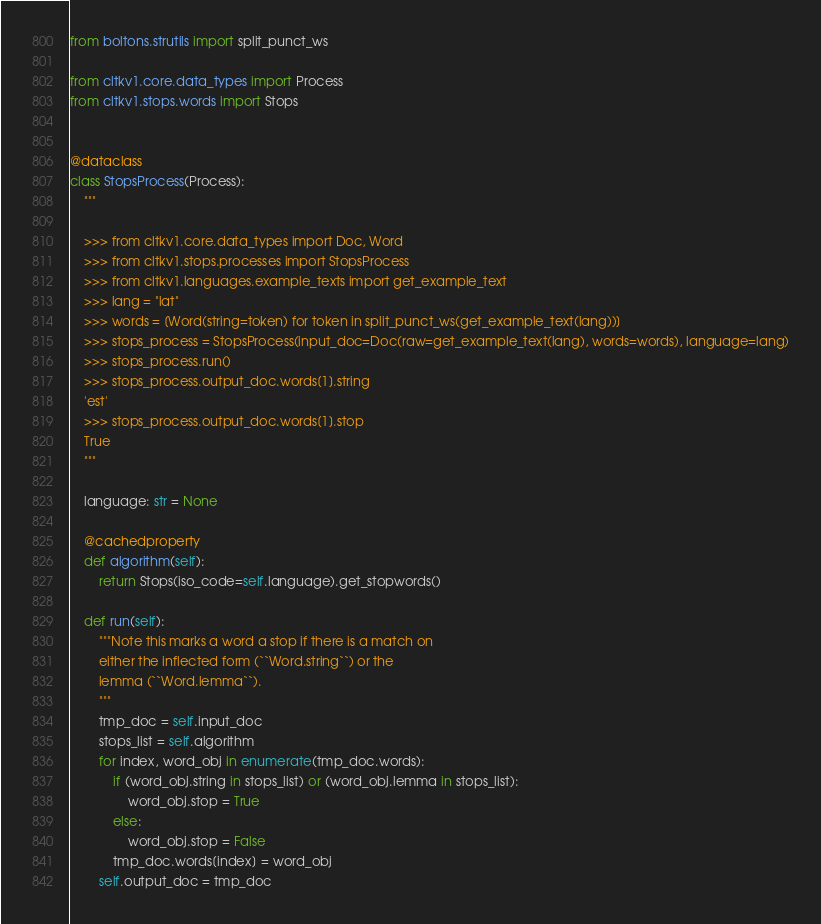<code> <loc_0><loc_0><loc_500><loc_500><_Python_>from boltons.strutils import split_punct_ws

from cltkv1.core.data_types import Process
from cltkv1.stops.words import Stops


@dataclass
class StopsProcess(Process):
    """

    >>> from cltkv1.core.data_types import Doc, Word
    >>> from cltkv1.stops.processes import StopsProcess
    >>> from cltkv1.languages.example_texts import get_example_text
    >>> lang = "lat"
    >>> words = [Word(string=token) for token in split_punct_ws(get_example_text(lang))]
    >>> stops_process = StopsProcess(input_doc=Doc(raw=get_example_text(lang), words=words), language=lang)
    >>> stops_process.run()
    >>> stops_process.output_doc.words[1].string
    'est'
    >>> stops_process.output_doc.words[1].stop
    True
    """

    language: str = None

    @cachedproperty
    def algorithm(self):
        return Stops(iso_code=self.language).get_stopwords()

    def run(self):
        """Note this marks a word a stop if there is a match on
        either the inflected form (``Word.string``) or the
        lemma (``Word.lemma``).
        """
        tmp_doc = self.input_doc
        stops_list = self.algorithm
        for index, word_obj in enumerate(tmp_doc.words):
            if (word_obj.string in stops_list) or (word_obj.lemma in stops_list):
                word_obj.stop = True
            else:
                word_obj.stop = False
            tmp_doc.words[index] = word_obj
        self.output_doc = tmp_doc
</code> 